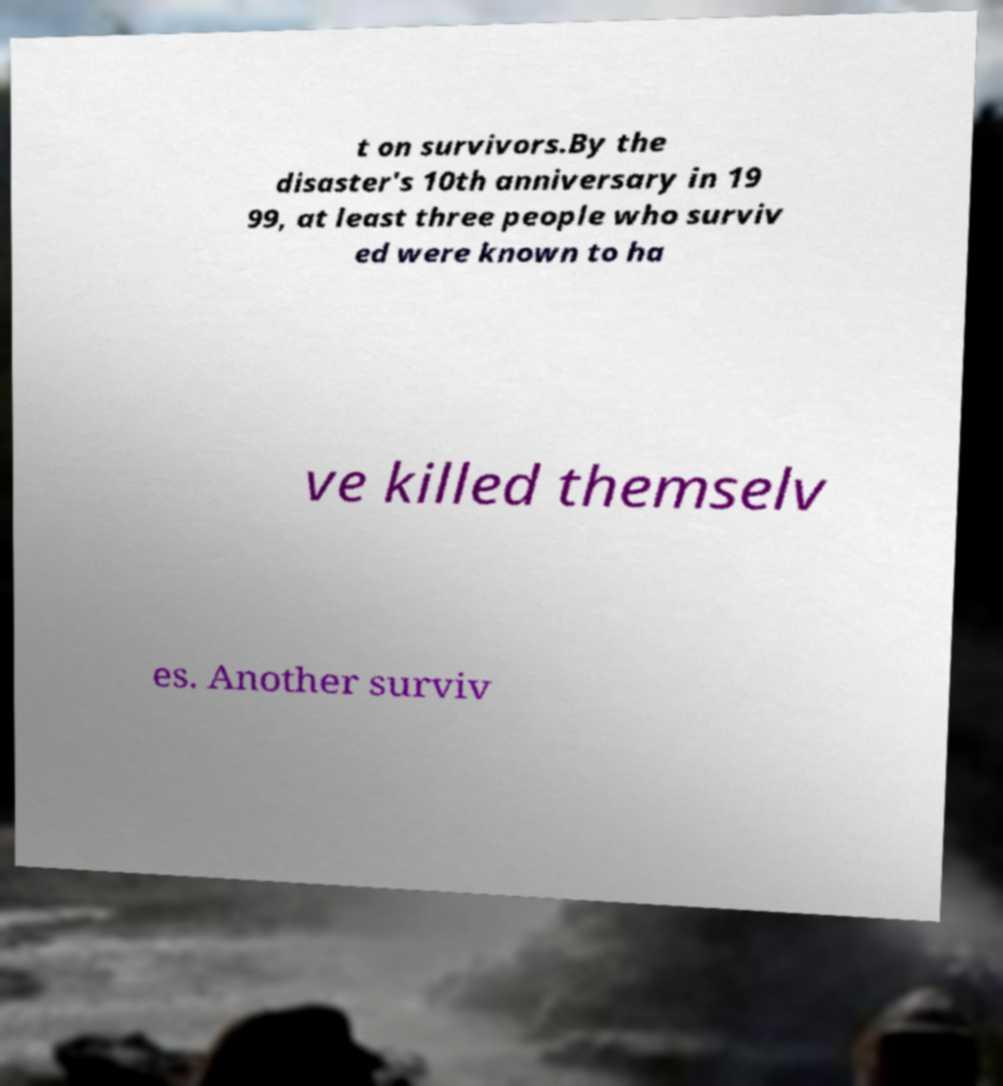Please identify and transcribe the text found in this image. t on survivors.By the disaster's 10th anniversary in 19 99, at least three people who surviv ed were known to ha ve killed themselv es. Another surviv 